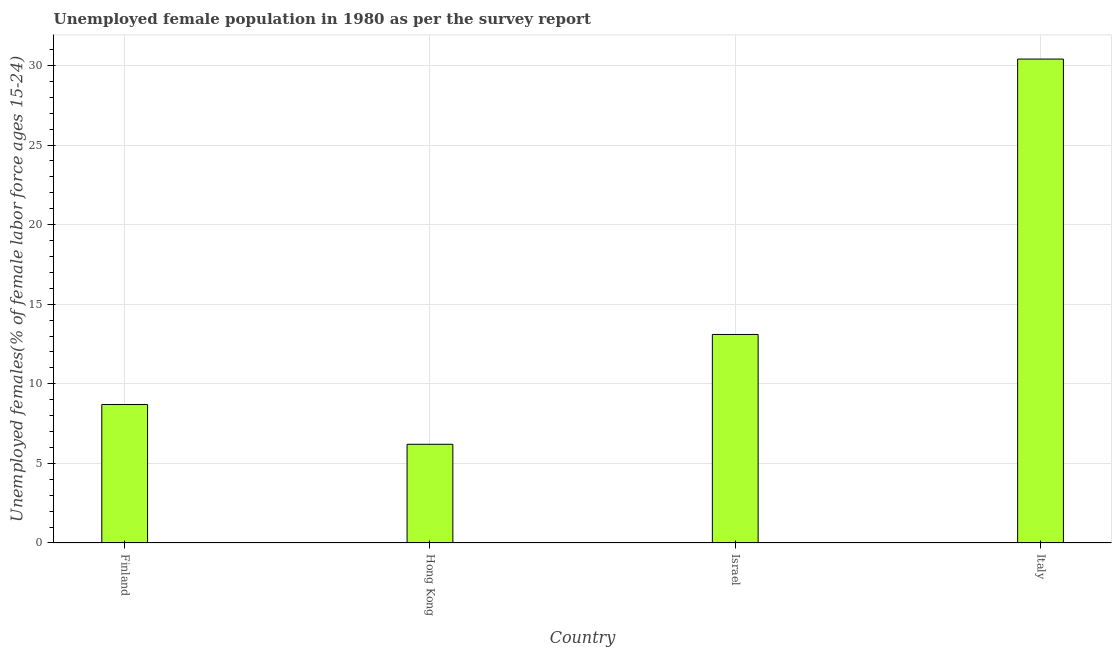What is the title of the graph?
Offer a terse response. Unemployed female population in 1980 as per the survey report. What is the label or title of the X-axis?
Keep it short and to the point. Country. What is the label or title of the Y-axis?
Keep it short and to the point. Unemployed females(% of female labor force ages 15-24). What is the unemployed female youth in Israel?
Your answer should be compact. 13.1. Across all countries, what is the maximum unemployed female youth?
Your answer should be very brief. 30.4. Across all countries, what is the minimum unemployed female youth?
Make the answer very short. 6.2. In which country was the unemployed female youth minimum?
Offer a terse response. Hong Kong. What is the sum of the unemployed female youth?
Provide a short and direct response. 58.4. What is the average unemployed female youth per country?
Your answer should be compact. 14.6. What is the median unemployed female youth?
Your answer should be very brief. 10.9. What is the ratio of the unemployed female youth in Israel to that in Italy?
Offer a very short reply. 0.43. Is the unemployed female youth in Finland less than that in Hong Kong?
Keep it short and to the point. No. What is the difference between the highest and the second highest unemployed female youth?
Your response must be concise. 17.3. What is the difference between the highest and the lowest unemployed female youth?
Your answer should be very brief. 24.2. In how many countries, is the unemployed female youth greater than the average unemployed female youth taken over all countries?
Offer a very short reply. 1. How many bars are there?
Your answer should be compact. 4. Are all the bars in the graph horizontal?
Your answer should be very brief. No. Are the values on the major ticks of Y-axis written in scientific E-notation?
Your response must be concise. No. What is the Unemployed females(% of female labor force ages 15-24) in Finland?
Your answer should be very brief. 8.7. What is the Unemployed females(% of female labor force ages 15-24) in Hong Kong?
Offer a very short reply. 6.2. What is the Unemployed females(% of female labor force ages 15-24) of Israel?
Make the answer very short. 13.1. What is the Unemployed females(% of female labor force ages 15-24) in Italy?
Give a very brief answer. 30.4. What is the difference between the Unemployed females(% of female labor force ages 15-24) in Finland and Hong Kong?
Make the answer very short. 2.5. What is the difference between the Unemployed females(% of female labor force ages 15-24) in Finland and Israel?
Make the answer very short. -4.4. What is the difference between the Unemployed females(% of female labor force ages 15-24) in Finland and Italy?
Offer a very short reply. -21.7. What is the difference between the Unemployed females(% of female labor force ages 15-24) in Hong Kong and Israel?
Give a very brief answer. -6.9. What is the difference between the Unemployed females(% of female labor force ages 15-24) in Hong Kong and Italy?
Make the answer very short. -24.2. What is the difference between the Unemployed females(% of female labor force ages 15-24) in Israel and Italy?
Make the answer very short. -17.3. What is the ratio of the Unemployed females(% of female labor force ages 15-24) in Finland to that in Hong Kong?
Offer a terse response. 1.4. What is the ratio of the Unemployed females(% of female labor force ages 15-24) in Finland to that in Israel?
Make the answer very short. 0.66. What is the ratio of the Unemployed females(% of female labor force ages 15-24) in Finland to that in Italy?
Your answer should be very brief. 0.29. What is the ratio of the Unemployed females(% of female labor force ages 15-24) in Hong Kong to that in Israel?
Your answer should be compact. 0.47. What is the ratio of the Unemployed females(% of female labor force ages 15-24) in Hong Kong to that in Italy?
Your answer should be very brief. 0.2. What is the ratio of the Unemployed females(% of female labor force ages 15-24) in Israel to that in Italy?
Offer a terse response. 0.43. 